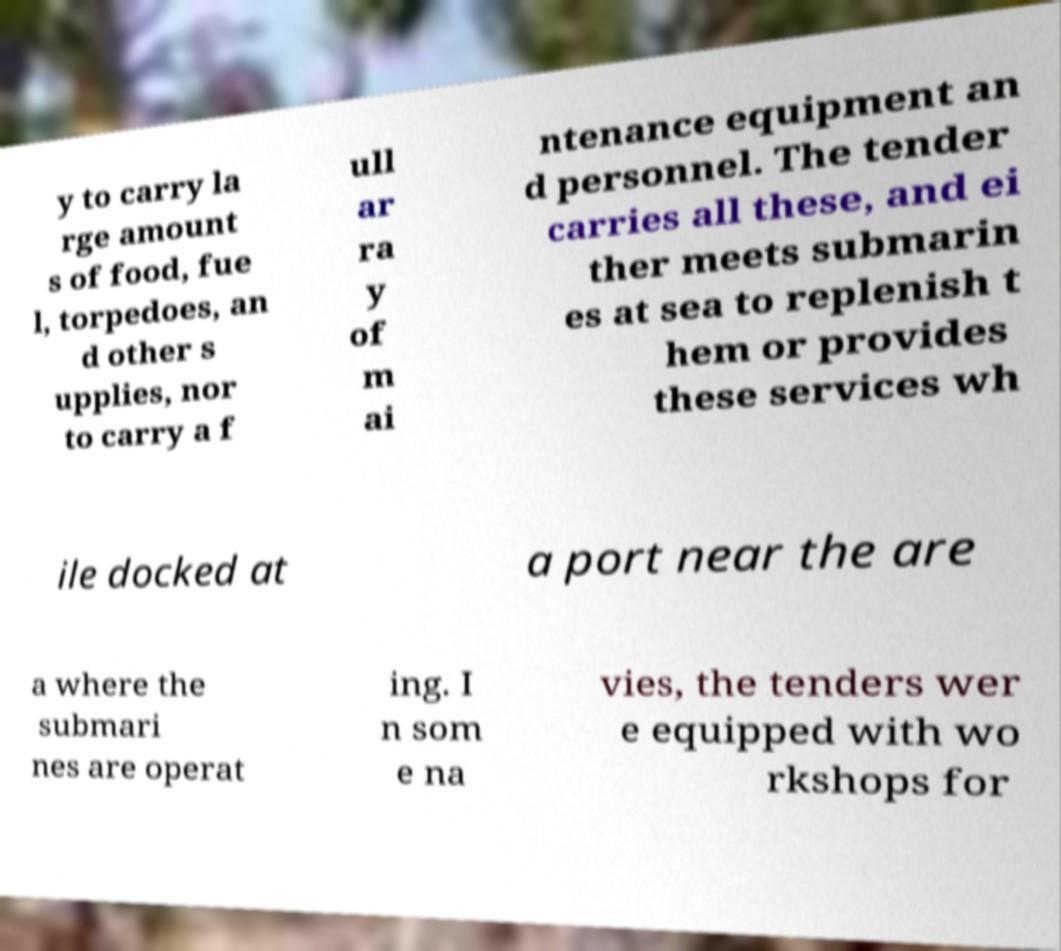There's text embedded in this image that I need extracted. Can you transcribe it verbatim? y to carry la rge amount s of food, fue l, torpedoes, an d other s upplies, nor to carry a f ull ar ra y of m ai ntenance equipment an d personnel. The tender carries all these, and ei ther meets submarin es at sea to replenish t hem or provides these services wh ile docked at a port near the are a where the submari nes are operat ing. I n som e na vies, the tenders wer e equipped with wo rkshops for 